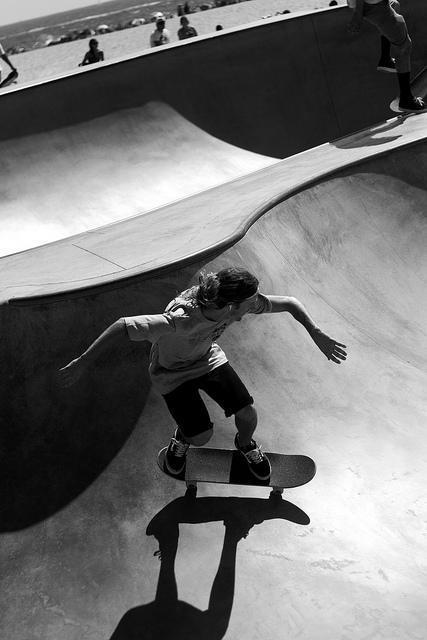How many skateboards can be seen?
Give a very brief answer. 1. How many people are in the picture?
Give a very brief answer. 2. 